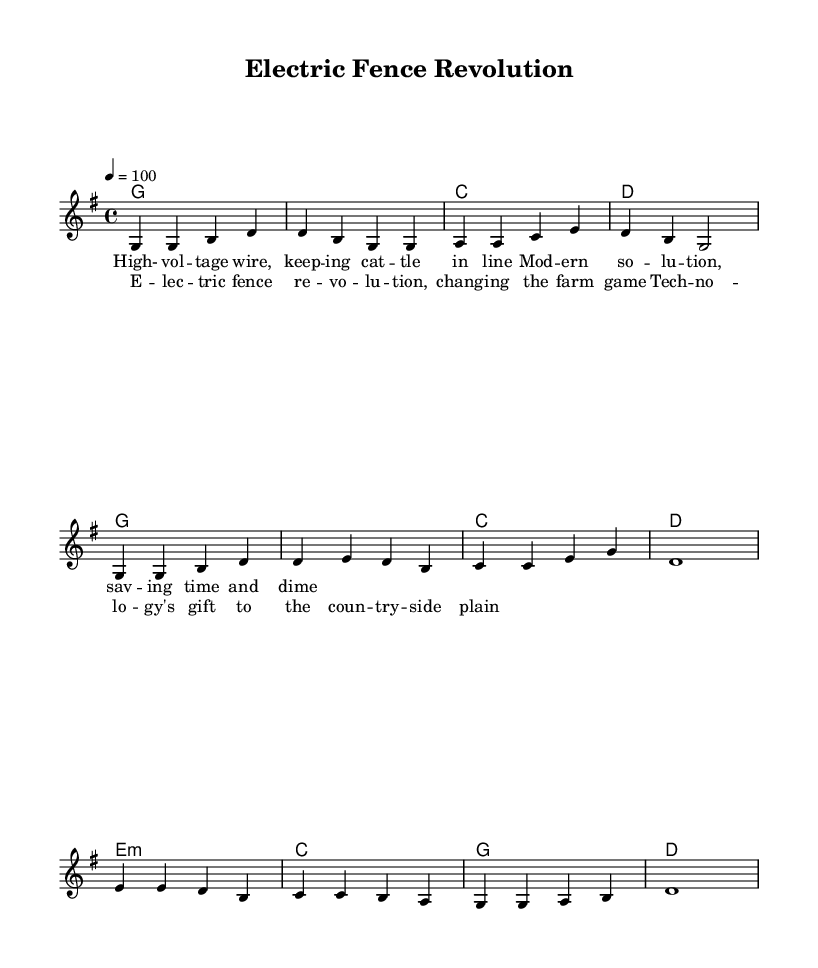What is the key signature of this music? The key signature is G major, which has one sharp (F#).
Answer: G major What is the time signature of this music? The time signature is 4/4, indicating four beats per measure.
Answer: 4/4 What is the tempo marking for this piece? The tempo marking indicates a speed of 100 beats per minute, as denoted by "4 = 100".
Answer: 100 What is the main theme of the chorus? The chorus discusses the "Electric Fence Revolution," highlighting how technology affects farming.
Answer: Electric Fence Revolution In which section does the line "High-voltage wire, keeping cattle in line" appear? This line appears in the verse section, as indicated by the alignment of the lyrics with the melody.
Answer: Verse How many measures are in the bridge section of the piece? The bridge section consists of four measures, as indicated by the grouping in the melody and harmonies.
Answer: Four What type of chords are used in the bridge? The bridge features a minor chord (e minor) followed by major chords (C and G) and ends with D major.
Answer: E minor 